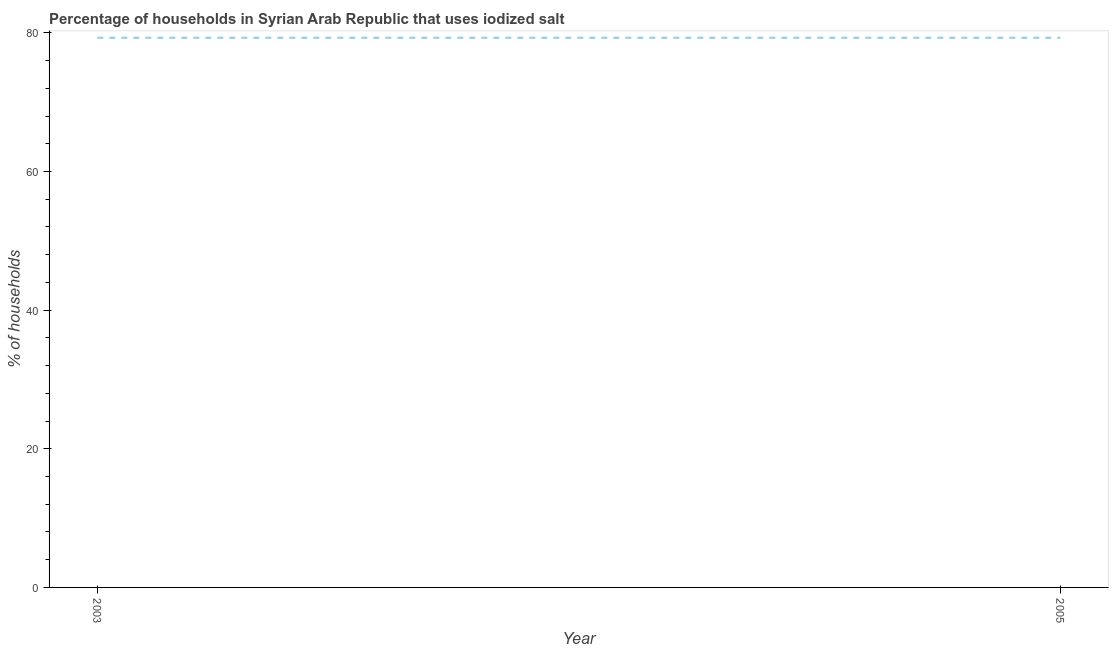What is the percentage of households where iodized salt is consumed in 2005?
Provide a short and direct response. 79.3. Across all years, what is the maximum percentage of households where iodized salt is consumed?
Make the answer very short. 79.3. Across all years, what is the minimum percentage of households where iodized salt is consumed?
Your response must be concise. 79.3. In which year was the percentage of households where iodized salt is consumed maximum?
Your response must be concise. 2003. What is the sum of the percentage of households where iodized salt is consumed?
Offer a terse response. 158.6. What is the difference between the percentage of households where iodized salt is consumed in 2003 and 2005?
Make the answer very short. 0. What is the average percentage of households where iodized salt is consumed per year?
Ensure brevity in your answer.  79.3. What is the median percentage of households where iodized salt is consumed?
Your response must be concise. 79.3. In how many years, is the percentage of households where iodized salt is consumed greater than 52 %?
Offer a very short reply. 2. Do a majority of the years between 2003 and 2005 (inclusive) have percentage of households where iodized salt is consumed greater than 40 %?
Give a very brief answer. Yes. What is the ratio of the percentage of households where iodized salt is consumed in 2003 to that in 2005?
Offer a very short reply. 1. Is the percentage of households where iodized salt is consumed in 2003 less than that in 2005?
Provide a succinct answer. No. Does the percentage of households where iodized salt is consumed monotonically increase over the years?
Offer a very short reply. No. How many lines are there?
Make the answer very short. 1. What is the difference between two consecutive major ticks on the Y-axis?
Your response must be concise. 20. What is the title of the graph?
Keep it short and to the point. Percentage of households in Syrian Arab Republic that uses iodized salt. What is the label or title of the X-axis?
Your response must be concise. Year. What is the label or title of the Y-axis?
Give a very brief answer. % of households. What is the % of households of 2003?
Ensure brevity in your answer.  79.3. What is the % of households of 2005?
Ensure brevity in your answer.  79.3. What is the difference between the % of households in 2003 and 2005?
Offer a terse response. 0. 